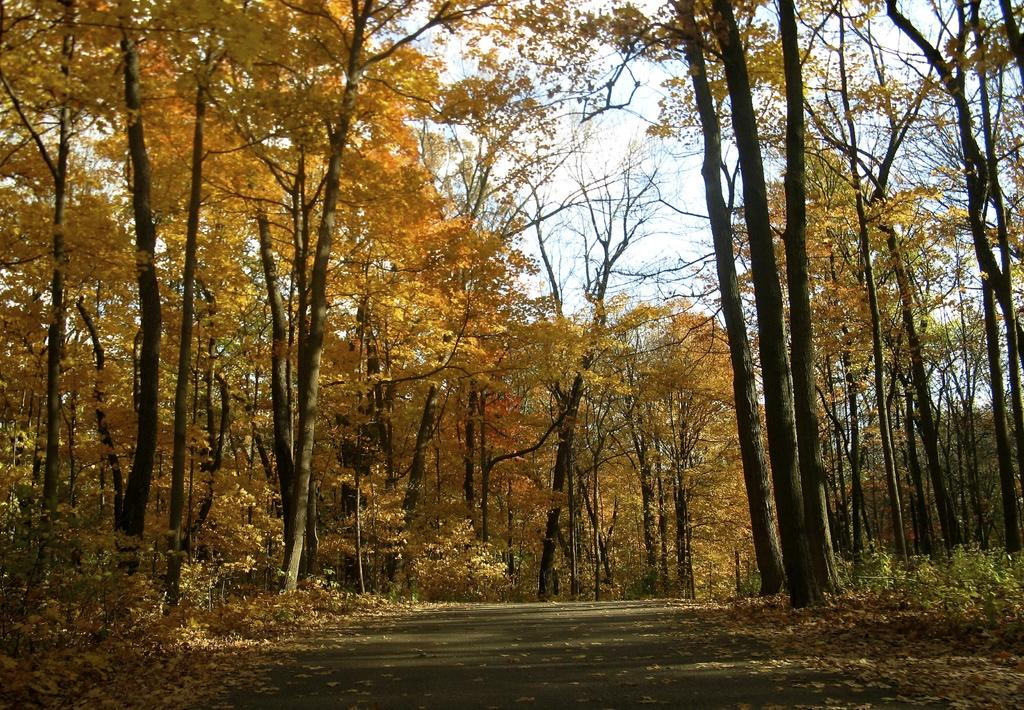What type of natural vegetation can be seen in the image? There are trees in the image. What celestial bodies are visible in the image? There are planets visible in the image. What type of man-made structure can be seen in the image? There is a road in the image. What is visible in the background of the image? The sky is visible in the background of the image. Can you see a clam near the trees in the image? There is no clam present in the image; it is not a marine environment. What type of gate can be seen in the image? There is no gate present in the image. 